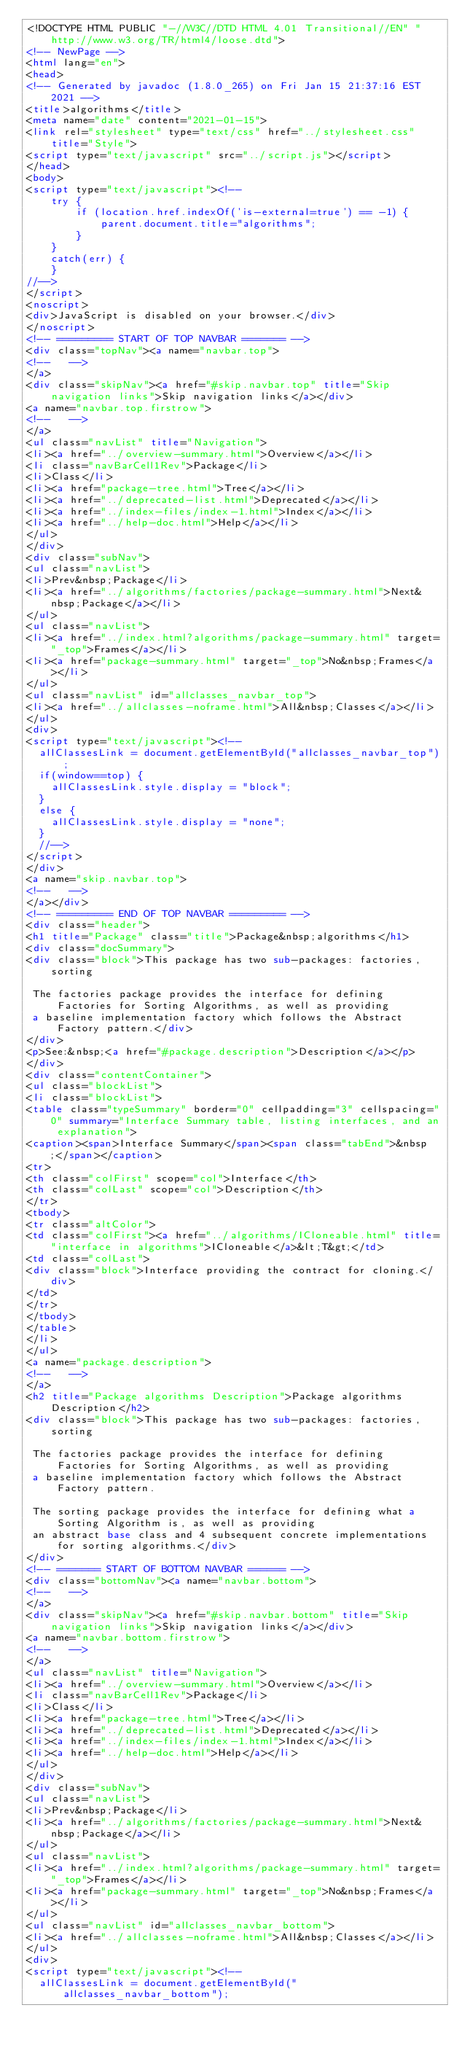<code> <loc_0><loc_0><loc_500><loc_500><_HTML_><!DOCTYPE HTML PUBLIC "-//W3C//DTD HTML 4.01 Transitional//EN" "http://www.w3.org/TR/html4/loose.dtd">
<!-- NewPage -->
<html lang="en">
<head>
<!-- Generated by javadoc (1.8.0_265) on Fri Jan 15 21:37:16 EST 2021 -->
<title>algorithms</title>
<meta name="date" content="2021-01-15">
<link rel="stylesheet" type="text/css" href="../stylesheet.css" title="Style">
<script type="text/javascript" src="../script.js"></script>
</head>
<body>
<script type="text/javascript"><!--
    try {
        if (location.href.indexOf('is-external=true') == -1) {
            parent.document.title="algorithms";
        }
    }
    catch(err) {
    }
//-->
</script>
<noscript>
<div>JavaScript is disabled on your browser.</div>
</noscript>
<!-- ========= START OF TOP NAVBAR ======= -->
<div class="topNav"><a name="navbar.top">
<!--   -->
</a>
<div class="skipNav"><a href="#skip.navbar.top" title="Skip navigation links">Skip navigation links</a></div>
<a name="navbar.top.firstrow">
<!--   -->
</a>
<ul class="navList" title="Navigation">
<li><a href="../overview-summary.html">Overview</a></li>
<li class="navBarCell1Rev">Package</li>
<li>Class</li>
<li><a href="package-tree.html">Tree</a></li>
<li><a href="../deprecated-list.html">Deprecated</a></li>
<li><a href="../index-files/index-1.html">Index</a></li>
<li><a href="../help-doc.html">Help</a></li>
</ul>
</div>
<div class="subNav">
<ul class="navList">
<li>Prev&nbsp;Package</li>
<li><a href="../algorithms/factories/package-summary.html">Next&nbsp;Package</a></li>
</ul>
<ul class="navList">
<li><a href="../index.html?algorithms/package-summary.html" target="_top">Frames</a></li>
<li><a href="package-summary.html" target="_top">No&nbsp;Frames</a></li>
</ul>
<ul class="navList" id="allclasses_navbar_top">
<li><a href="../allclasses-noframe.html">All&nbsp;Classes</a></li>
</ul>
<div>
<script type="text/javascript"><!--
  allClassesLink = document.getElementById("allclasses_navbar_top");
  if(window==top) {
    allClassesLink.style.display = "block";
  }
  else {
    allClassesLink.style.display = "none";
  }
  //-->
</script>
</div>
<a name="skip.navbar.top">
<!--   -->
</a></div>
<!-- ========= END OF TOP NAVBAR ========= -->
<div class="header">
<h1 title="Package" class="title">Package&nbsp;algorithms</h1>
<div class="docSummary">
<div class="block">This package has two sub-packages: factories, sorting

 The factories package provides the interface for defining Factories for Sorting Algorithms, as well as providing
 a baseline implementation factory which follows the Abstract Factory pattern.</div>
</div>
<p>See:&nbsp;<a href="#package.description">Description</a></p>
</div>
<div class="contentContainer">
<ul class="blockList">
<li class="blockList">
<table class="typeSummary" border="0" cellpadding="3" cellspacing="0" summary="Interface Summary table, listing interfaces, and an explanation">
<caption><span>Interface Summary</span><span class="tabEnd">&nbsp;</span></caption>
<tr>
<th class="colFirst" scope="col">Interface</th>
<th class="colLast" scope="col">Description</th>
</tr>
<tbody>
<tr class="altColor">
<td class="colFirst"><a href="../algorithms/ICloneable.html" title="interface in algorithms">ICloneable</a>&lt;T&gt;</td>
<td class="colLast">
<div class="block">Interface providing the contract for cloning.</div>
</td>
</tr>
</tbody>
</table>
</li>
</ul>
<a name="package.description">
<!--   -->
</a>
<h2 title="Package algorithms Description">Package algorithms Description</h2>
<div class="block">This package has two sub-packages: factories, sorting

 The factories package provides the interface for defining Factories for Sorting Algorithms, as well as providing
 a baseline implementation factory which follows the Abstract Factory pattern.

 The sorting package provides the interface for defining what a Sorting Algorithm is, as well as providing
 an abstract base class and 4 subsequent concrete implementations for sorting algorithms.</div>
</div>
<!-- ======= START OF BOTTOM NAVBAR ====== -->
<div class="bottomNav"><a name="navbar.bottom">
<!--   -->
</a>
<div class="skipNav"><a href="#skip.navbar.bottom" title="Skip navigation links">Skip navigation links</a></div>
<a name="navbar.bottom.firstrow">
<!--   -->
</a>
<ul class="navList" title="Navigation">
<li><a href="../overview-summary.html">Overview</a></li>
<li class="navBarCell1Rev">Package</li>
<li>Class</li>
<li><a href="package-tree.html">Tree</a></li>
<li><a href="../deprecated-list.html">Deprecated</a></li>
<li><a href="../index-files/index-1.html">Index</a></li>
<li><a href="../help-doc.html">Help</a></li>
</ul>
</div>
<div class="subNav">
<ul class="navList">
<li>Prev&nbsp;Package</li>
<li><a href="../algorithms/factories/package-summary.html">Next&nbsp;Package</a></li>
</ul>
<ul class="navList">
<li><a href="../index.html?algorithms/package-summary.html" target="_top">Frames</a></li>
<li><a href="package-summary.html" target="_top">No&nbsp;Frames</a></li>
</ul>
<ul class="navList" id="allclasses_navbar_bottom">
<li><a href="../allclasses-noframe.html">All&nbsp;Classes</a></li>
</ul>
<div>
<script type="text/javascript"><!--
  allClassesLink = document.getElementById("allclasses_navbar_bottom");</code> 